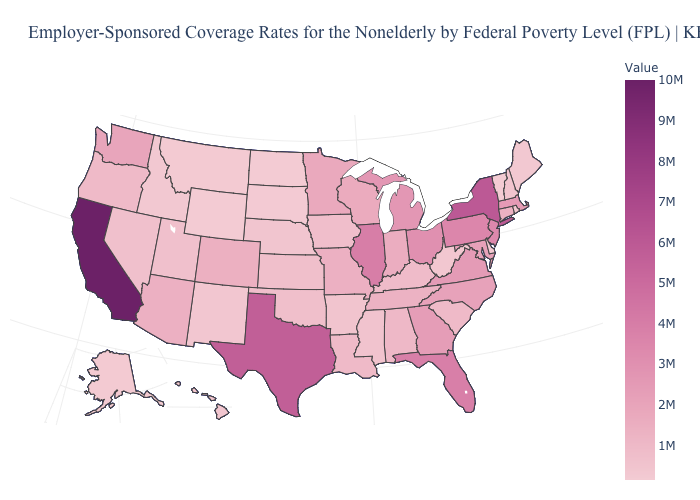Which states hav the highest value in the West?
Keep it brief. California. Which states have the lowest value in the USA?
Answer briefly. Wyoming. Does Texas have a lower value than Nebraska?
Write a very short answer. No. Does the map have missing data?
Quick response, please. No. Does California have the highest value in the USA?
Write a very short answer. Yes. Among the states that border Nevada , which have the lowest value?
Quick response, please. Idaho. Does Utah have a higher value than New Jersey?
Quick response, please. No. 